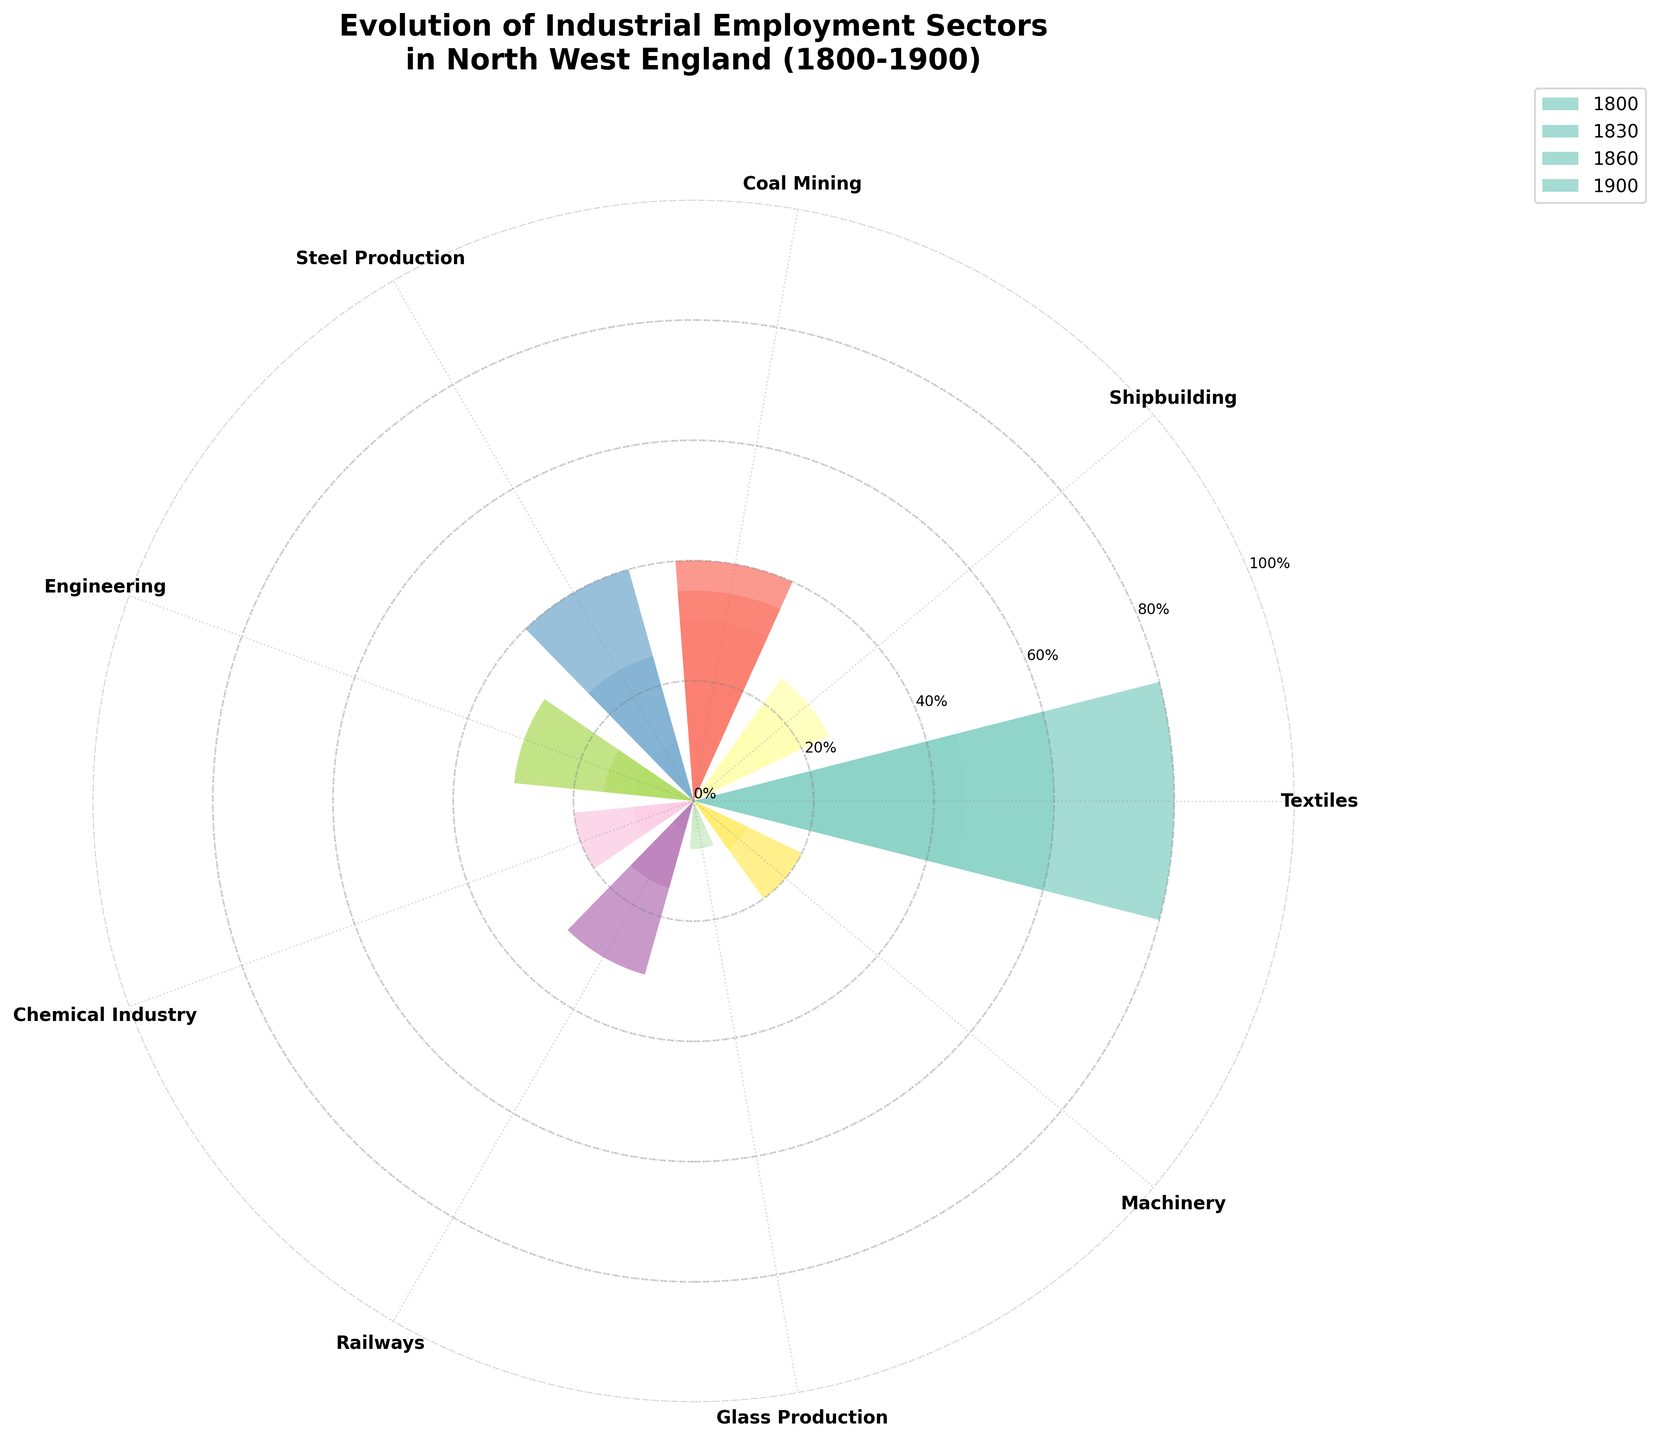What's the title of the figure? The title is usually placed at the top of the figure. In this case, the title should be "Evolution of Industrial Employment Sectors in North West England (1800-1900)" as described in the code.
Answer: Evolution of Industrial Employment Sectors in North West England (1800-1900) Which industry shows the most significant increase in employment from 1800 to 1900? By observing the bars representing various industries, we can see that the Textiles industry has the highest increase, starting at 30 in 1800 and reaching 80 in 1900.
Answer: Textiles What is the percentage increase in employment in the Chemical Industry from 1800 to 1900? The value for the Chemical Industry in 1800 is 2, and in 1900 it is 20. The percentage increase is calculated as ((20-2)/2) * 100.
Answer: 900% Compare the employment in Coal Mining between 1860 and 1900. Did it increase or decrease? By observing the height of the bars, the employment in Coal Mining in 1860 is 40 and in 1900 is 35. Thus, it slightly decreased.
Answer: Decrease Which two industries had the same employment levels in 1830? Looking at the bars for each industry in 1830, both Glass Production and Machinery had employment levels of 5.
Answer: Glass Production and Machinery What industry emerged between 1800 and 1900 that didn't exist in 1800? By comparing the bars labelled for the different years, it's clear that the Railways industry appears in 1830 with an employment level of 5, while it was at 0 in 1800.
Answer: Railways What is the average employment of the Engineering industry across the years shown? The employment numbers for Engineering in the years 1800, 1830, 1860, and 1900 are 5, 10, 15, and 30 respectively. The average is calculated as (5+10+15+30)/4.
Answer: 15 Which industry had 10% employment in 1800 and showed little growth by 1900? By looking at the employment values, Shipbuilding had 10% employment in 1800 and reached only 25% by 1900, showing minimal growth compared to others.
Answer: Shipbuilding Which industry shows the smallest increase in employment between 1800 and 1900? By comparing the bars, Glass Production shows the smallest increase in employment, moving from 2 to 8.
Answer: Glass Production 